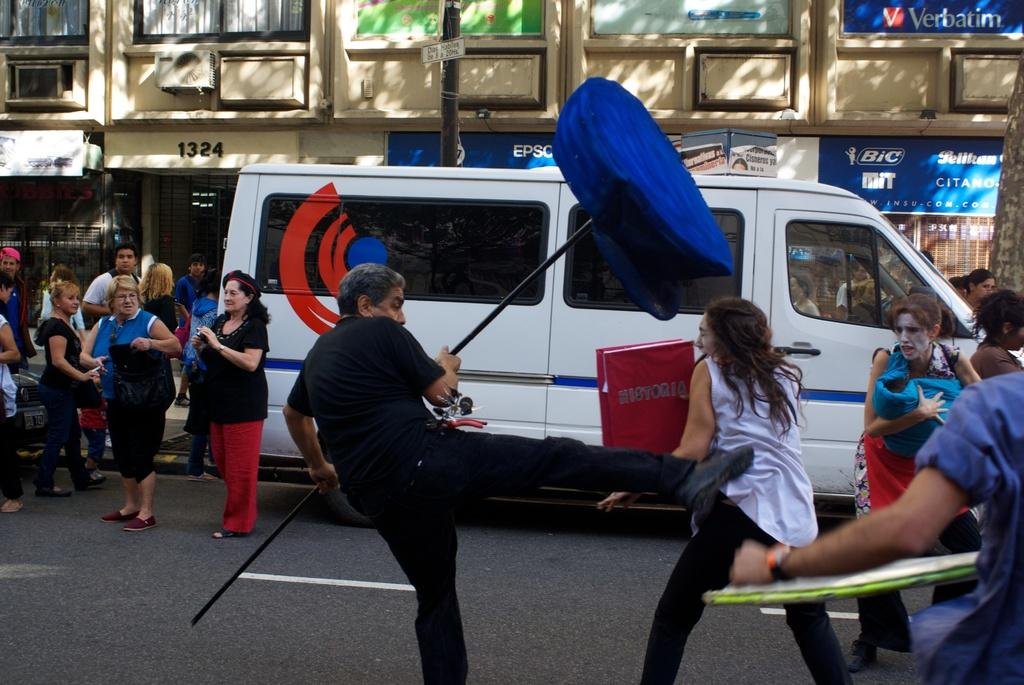<image>
Summarize the visual content of the image. A man and a woman are engaged in a fight in a busy street while a crowd watches. The woman holds a large book that says Historia 